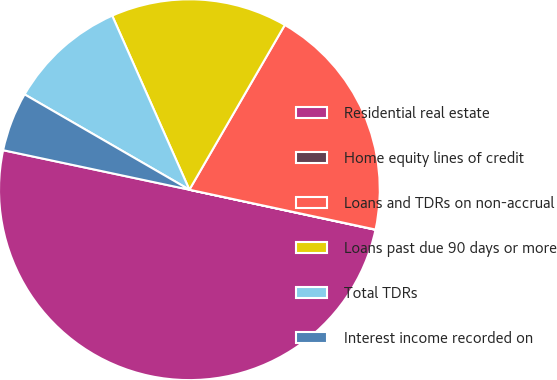Convert chart. <chart><loc_0><loc_0><loc_500><loc_500><pie_chart><fcel>Residential real estate<fcel>Home equity lines of credit<fcel>Loans and TDRs on non-accrual<fcel>Loans past due 90 days or more<fcel>Total TDRs<fcel>Interest income recorded on<nl><fcel>49.95%<fcel>0.02%<fcel>20.0%<fcel>15.0%<fcel>10.01%<fcel>5.02%<nl></chart> 